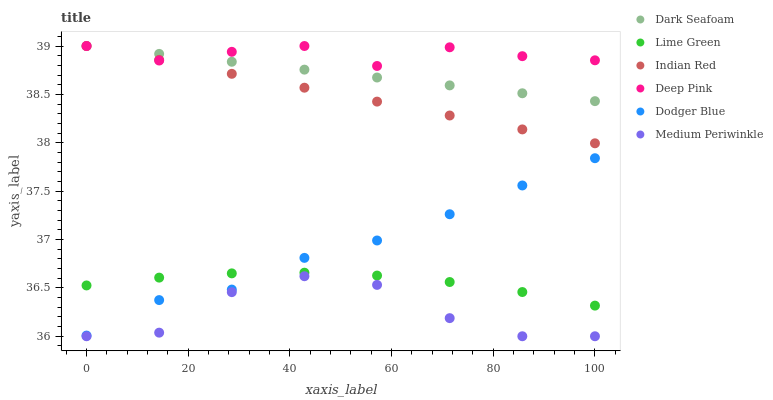Does Medium Periwinkle have the minimum area under the curve?
Answer yes or no. Yes. Does Deep Pink have the maximum area under the curve?
Answer yes or no. Yes. Does Dark Seafoam have the minimum area under the curve?
Answer yes or no. No. Does Dark Seafoam have the maximum area under the curve?
Answer yes or no. No. Is Indian Red the smoothest?
Answer yes or no. Yes. Is Medium Periwinkle the roughest?
Answer yes or no. Yes. Is Dark Seafoam the smoothest?
Answer yes or no. No. Is Dark Seafoam the roughest?
Answer yes or no. No. Does Medium Periwinkle have the lowest value?
Answer yes or no. Yes. Does Dark Seafoam have the lowest value?
Answer yes or no. No. Does Indian Red have the highest value?
Answer yes or no. Yes. Does Medium Periwinkle have the highest value?
Answer yes or no. No. Is Medium Periwinkle less than Dodger Blue?
Answer yes or no. Yes. Is Deep Pink greater than Lime Green?
Answer yes or no. Yes. Does Dark Seafoam intersect Indian Red?
Answer yes or no. Yes. Is Dark Seafoam less than Indian Red?
Answer yes or no. No. Is Dark Seafoam greater than Indian Red?
Answer yes or no. No. Does Medium Periwinkle intersect Dodger Blue?
Answer yes or no. No. 